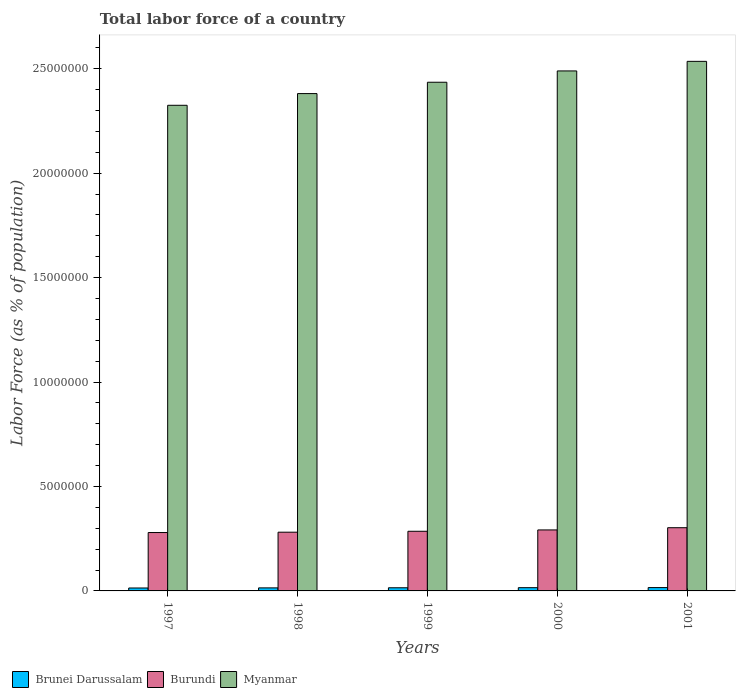How many groups of bars are there?
Your answer should be compact. 5. Are the number of bars per tick equal to the number of legend labels?
Keep it short and to the point. Yes. How many bars are there on the 1st tick from the left?
Your response must be concise. 3. How many bars are there on the 5th tick from the right?
Ensure brevity in your answer.  3. What is the label of the 2nd group of bars from the left?
Offer a very short reply. 1998. What is the percentage of labor force in Brunei Darussalam in 1999?
Offer a very short reply. 1.51e+05. Across all years, what is the maximum percentage of labor force in Burundi?
Your response must be concise. 3.03e+06. Across all years, what is the minimum percentage of labor force in Burundi?
Give a very brief answer. 2.79e+06. What is the total percentage of labor force in Myanmar in the graph?
Ensure brevity in your answer.  1.22e+08. What is the difference between the percentage of labor force in Brunei Darussalam in 1998 and that in 2000?
Provide a short and direct response. -1.00e+04. What is the difference between the percentage of labor force in Myanmar in 2000 and the percentage of labor force in Brunei Darussalam in 2001?
Provide a succinct answer. 2.47e+07. What is the average percentage of labor force in Brunei Darussalam per year?
Give a very brief answer. 1.50e+05. In the year 2000, what is the difference between the percentage of labor force in Burundi and percentage of labor force in Myanmar?
Make the answer very short. -2.20e+07. What is the ratio of the percentage of labor force in Burundi in 1997 to that in 2001?
Provide a succinct answer. 0.92. Is the percentage of labor force in Myanmar in 1999 less than that in 2001?
Provide a succinct answer. Yes. What is the difference between the highest and the second highest percentage of labor force in Myanmar?
Provide a short and direct response. 4.58e+05. What is the difference between the highest and the lowest percentage of labor force in Myanmar?
Ensure brevity in your answer.  2.10e+06. What does the 3rd bar from the left in 2000 represents?
Keep it short and to the point. Myanmar. What does the 3rd bar from the right in 2000 represents?
Provide a short and direct response. Brunei Darussalam. Is it the case that in every year, the sum of the percentage of labor force in Myanmar and percentage of labor force in Brunei Darussalam is greater than the percentage of labor force in Burundi?
Offer a very short reply. Yes. How many bars are there?
Provide a succinct answer. 15. Are all the bars in the graph horizontal?
Your response must be concise. No. How many years are there in the graph?
Your answer should be very brief. 5. What is the difference between two consecutive major ticks on the Y-axis?
Make the answer very short. 5.00e+06. Does the graph contain grids?
Make the answer very short. No. How are the legend labels stacked?
Your answer should be very brief. Horizontal. What is the title of the graph?
Give a very brief answer. Total labor force of a country. Does "High income: OECD" appear as one of the legend labels in the graph?
Offer a very short reply. No. What is the label or title of the Y-axis?
Provide a short and direct response. Labor Force (as % of population). What is the Labor Force (as % of population) in Brunei Darussalam in 1997?
Your response must be concise. 1.41e+05. What is the Labor Force (as % of population) of Burundi in 1997?
Provide a short and direct response. 2.79e+06. What is the Labor Force (as % of population) in Myanmar in 1997?
Your answer should be compact. 2.32e+07. What is the Labor Force (as % of population) in Brunei Darussalam in 1998?
Provide a succinct answer. 1.45e+05. What is the Labor Force (as % of population) in Burundi in 1998?
Ensure brevity in your answer.  2.81e+06. What is the Labor Force (as % of population) of Myanmar in 1998?
Provide a succinct answer. 2.38e+07. What is the Labor Force (as % of population) in Brunei Darussalam in 1999?
Provide a succinct answer. 1.51e+05. What is the Labor Force (as % of population) of Burundi in 1999?
Make the answer very short. 2.86e+06. What is the Labor Force (as % of population) of Myanmar in 1999?
Ensure brevity in your answer.  2.44e+07. What is the Labor Force (as % of population) in Brunei Darussalam in 2000?
Ensure brevity in your answer.  1.55e+05. What is the Labor Force (as % of population) in Burundi in 2000?
Keep it short and to the point. 2.92e+06. What is the Labor Force (as % of population) of Myanmar in 2000?
Offer a terse response. 2.49e+07. What is the Labor Force (as % of population) in Brunei Darussalam in 2001?
Offer a very short reply. 1.60e+05. What is the Labor Force (as % of population) in Burundi in 2001?
Ensure brevity in your answer.  3.03e+06. What is the Labor Force (as % of population) in Myanmar in 2001?
Make the answer very short. 2.54e+07. Across all years, what is the maximum Labor Force (as % of population) in Brunei Darussalam?
Keep it short and to the point. 1.60e+05. Across all years, what is the maximum Labor Force (as % of population) in Burundi?
Offer a very short reply. 3.03e+06. Across all years, what is the maximum Labor Force (as % of population) in Myanmar?
Ensure brevity in your answer.  2.54e+07. Across all years, what is the minimum Labor Force (as % of population) of Brunei Darussalam?
Provide a succinct answer. 1.41e+05. Across all years, what is the minimum Labor Force (as % of population) of Burundi?
Provide a short and direct response. 2.79e+06. Across all years, what is the minimum Labor Force (as % of population) in Myanmar?
Provide a short and direct response. 2.32e+07. What is the total Labor Force (as % of population) of Brunei Darussalam in the graph?
Your response must be concise. 7.52e+05. What is the total Labor Force (as % of population) of Burundi in the graph?
Make the answer very short. 1.44e+07. What is the total Labor Force (as % of population) of Myanmar in the graph?
Offer a terse response. 1.22e+08. What is the difference between the Labor Force (as % of population) of Brunei Darussalam in 1997 and that in 1998?
Your response must be concise. -4952. What is the difference between the Labor Force (as % of population) in Burundi in 1997 and that in 1998?
Offer a terse response. -1.61e+04. What is the difference between the Labor Force (as % of population) of Myanmar in 1997 and that in 1998?
Your response must be concise. -5.60e+05. What is the difference between the Labor Force (as % of population) of Brunei Darussalam in 1997 and that in 1999?
Make the answer very short. -1.00e+04. What is the difference between the Labor Force (as % of population) in Burundi in 1997 and that in 1999?
Your answer should be very brief. -6.08e+04. What is the difference between the Labor Force (as % of population) in Myanmar in 1997 and that in 1999?
Provide a short and direct response. -1.10e+06. What is the difference between the Labor Force (as % of population) of Brunei Darussalam in 1997 and that in 2000?
Provide a short and direct response. -1.50e+04. What is the difference between the Labor Force (as % of population) in Burundi in 1997 and that in 2000?
Your answer should be compact. -1.25e+05. What is the difference between the Labor Force (as % of population) in Myanmar in 1997 and that in 2000?
Your answer should be very brief. -1.64e+06. What is the difference between the Labor Force (as % of population) in Brunei Darussalam in 1997 and that in 2001?
Keep it short and to the point. -1.95e+04. What is the difference between the Labor Force (as % of population) of Burundi in 1997 and that in 2001?
Your response must be concise. -2.31e+05. What is the difference between the Labor Force (as % of population) of Myanmar in 1997 and that in 2001?
Offer a terse response. -2.10e+06. What is the difference between the Labor Force (as % of population) in Brunei Darussalam in 1998 and that in 1999?
Offer a terse response. -5076. What is the difference between the Labor Force (as % of population) of Burundi in 1998 and that in 1999?
Offer a terse response. -4.47e+04. What is the difference between the Labor Force (as % of population) of Myanmar in 1998 and that in 1999?
Your answer should be compact. -5.44e+05. What is the difference between the Labor Force (as % of population) in Brunei Darussalam in 1998 and that in 2000?
Your answer should be compact. -1.00e+04. What is the difference between the Labor Force (as % of population) of Burundi in 1998 and that in 2000?
Provide a short and direct response. -1.09e+05. What is the difference between the Labor Force (as % of population) of Myanmar in 1998 and that in 2000?
Keep it short and to the point. -1.09e+06. What is the difference between the Labor Force (as % of population) of Brunei Darussalam in 1998 and that in 2001?
Your answer should be very brief. -1.46e+04. What is the difference between the Labor Force (as % of population) in Burundi in 1998 and that in 2001?
Make the answer very short. -2.15e+05. What is the difference between the Labor Force (as % of population) of Myanmar in 1998 and that in 2001?
Give a very brief answer. -1.54e+06. What is the difference between the Labor Force (as % of population) of Brunei Darussalam in 1999 and that in 2000?
Your answer should be compact. -4948. What is the difference between the Labor Force (as % of population) in Burundi in 1999 and that in 2000?
Your response must be concise. -6.41e+04. What is the difference between the Labor Force (as % of population) in Myanmar in 1999 and that in 2000?
Offer a terse response. -5.42e+05. What is the difference between the Labor Force (as % of population) in Brunei Darussalam in 1999 and that in 2001?
Offer a terse response. -9478. What is the difference between the Labor Force (as % of population) of Burundi in 1999 and that in 2001?
Make the answer very short. -1.70e+05. What is the difference between the Labor Force (as % of population) in Myanmar in 1999 and that in 2001?
Offer a terse response. -1.00e+06. What is the difference between the Labor Force (as % of population) in Brunei Darussalam in 2000 and that in 2001?
Your answer should be compact. -4530. What is the difference between the Labor Force (as % of population) of Burundi in 2000 and that in 2001?
Make the answer very short. -1.06e+05. What is the difference between the Labor Force (as % of population) in Myanmar in 2000 and that in 2001?
Give a very brief answer. -4.58e+05. What is the difference between the Labor Force (as % of population) in Brunei Darussalam in 1997 and the Labor Force (as % of population) in Burundi in 1998?
Keep it short and to the point. -2.67e+06. What is the difference between the Labor Force (as % of population) in Brunei Darussalam in 1997 and the Labor Force (as % of population) in Myanmar in 1998?
Offer a very short reply. -2.37e+07. What is the difference between the Labor Force (as % of population) in Burundi in 1997 and the Labor Force (as % of population) in Myanmar in 1998?
Offer a terse response. -2.10e+07. What is the difference between the Labor Force (as % of population) in Brunei Darussalam in 1997 and the Labor Force (as % of population) in Burundi in 1999?
Give a very brief answer. -2.72e+06. What is the difference between the Labor Force (as % of population) of Brunei Darussalam in 1997 and the Labor Force (as % of population) of Myanmar in 1999?
Your answer should be very brief. -2.42e+07. What is the difference between the Labor Force (as % of population) in Burundi in 1997 and the Labor Force (as % of population) in Myanmar in 1999?
Keep it short and to the point. -2.16e+07. What is the difference between the Labor Force (as % of population) in Brunei Darussalam in 1997 and the Labor Force (as % of population) in Burundi in 2000?
Your response must be concise. -2.78e+06. What is the difference between the Labor Force (as % of population) of Brunei Darussalam in 1997 and the Labor Force (as % of population) of Myanmar in 2000?
Your response must be concise. -2.48e+07. What is the difference between the Labor Force (as % of population) in Burundi in 1997 and the Labor Force (as % of population) in Myanmar in 2000?
Your response must be concise. -2.21e+07. What is the difference between the Labor Force (as % of population) in Brunei Darussalam in 1997 and the Labor Force (as % of population) in Burundi in 2001?
Ensure brevity in your answer.  -2.89e+06. What is the difference between the Labor Force (as % of population) in Brunei Darussalam in 1997 and the Labor Force (as % of population) in Myanmar in 2001?
Your answer should be compact. -2.52e+07. What is the difference between the Labor Force (as % of population) of Burundi in 1997 and the Labor Force (as % of population) of Myanmar in 2001?
Your response must be concise. -2.26e+07. What is the difference between the Labor Force (as % of population) in Brunei Darussalam in 1998 and the Labor Force (as % of population) in Burundi in 1999?
Make the answer very short. -2.71e+06. What is the difference between the Labor Force (as % of population) in Brunei Darussalam in 1998 and the Labor Force (as % of population) in Myanmar in 1999?
Offer a very short reply. -2.42e+07. What is the difference between the Labor Force (as % of population) of Burundi in 1998 and the Labor Force (as % of population) of Myanmar in 1999?
Ensure brevity in your answer.  -2.15e+07. What is the difference between the Labor Force (as % of population) in Brunei Darussalam in 1998 and the Labor Force (as % of population) in Burundi in 2000?
Keep it short and to the point. -2.77e+06. What is the difference between the Labor Force (as % of population) of Brunei Darussalam in 1998 and the Labor Force (as % of population) of Myanmar in 2000?
Your response must be concise. -2.47e+07. What is the difference between the Labor Force (as % of population) in Burundi in 1998 and the Labor Force (as % of population) in Myanmar in 2000?
Your response must be concise. -2.21e+07. What is the difference between the Labor Force (as % of population) in Brunei Darussalam in 1998 and the Labor Force (as % of population) in Burundi in 2001?
Offer a terse response. -2.88e+06. What is the difference between the Labor Force (as % of population) of Brunei Darussalam in 1998 and the Labor Force (as % of population) of Myanmar in 2001?
Your answer should be very brief. -2.52e+07. What is the difference between the Labor Force (as % of population) of Burundi in 1998 and the Labor Force (as % of population) of Myanmar in 2001?
Your answer should be very brief. -2.25e+07. What is the difference between the Labor Force (as % of population) of Brunei Darussalam in 1999 and the Labor Force (as % of population) of Burundi in 2000?
Offer a terse response. -2.77e+06. What is the difference between the Labor Force (as % of population) of Brunei Darussalam in 1999 and the Labor Force (as % of population) of Myanmar in 2000?
Provide a short and direct response. -2.47e+07. What is the difference between the Labor Force (as % of population) of Burundi in 1999 and the Labor Force (as % of population) of Myanmar in 2000?
Keep it short and to the point. -2.20e+07. What is the difference between the Labor Force (as % of population) of Brunei Darussalam in 1999 and the Labor Force (as % of population) of Burundi in 2001?
Offer a terse response. -2.88e+06. What is the difference between the Labor Force (as % of population) in Brunei Darussalam in 1999 and the Labor Force (as % of population) in Myanmar in 2001?
Your response must be concise. -2.52e+07. What is the difference between the Labor Force (as % of population) of Burundi in 1999 and the Labor Force (as % of population) of Myanmar in 2001?
Make the answer very short. -2.25e+07. What is the difference between the Labor Force (as % of population) in Brunei Darussalam in 2000 and the Labor Force (as % of population) in Burundi in 2001?
Provide a succinct answer. -2.87e+06. What is the difference between the Labor Force (as % of population) in Brunei Darussalam in 2000 and the Labor Force (as % of population) in Myanmar in 2001?
Make the answer very short. -2.52e+07. What is the difference between the Labor Force (as % of population) of Burundi in 2000 and the Labor Force (as % of population) of Myanmar in 2001?
Give a very brief answer. -2.24e+07. What is the average Labor Force (as % of population) of Brunei Darussalam per year?
Provide a succinct answer. 1.50e+05. What is the average Labor Force (as % of population) in Burundi per year?
Provide a short and direct response. 2.88e+06. What is the average Labor Force (as % of population) of Myanmar per year?
Provide a succinct answer. 2.43e+07. In the year 1997, what is the difference between the Labor Force (as % of population) in Brunei Darussalam and Labor Force (as % of population) in Burundi?
Make the answer very short. -2.65e+06. In the year 1997, what is the difference between the Labor Force (as % of population) of Brunei Darussalam and Labor Force (as % of population) of Myanmar?
Keep it short and to the point. -2.31e+07. In the year 1997, what is the difference between the Labor Force (as % of population) of Burundi and Labor Force (as % of population) of Myanmar?
Provide a succinct answer. -2.05e+07. In the year 1998, what is the difference between the Labor Force (as % of population) in Brunei Darussalam and Labor Force (as % of population) in Burundi?
Your answer should be very brief. -2.67e+06. In the year 1998, what is the difference between the Labor Force (as % of population) in Brunei Darussalam and Labor Force (as % of population) in Myanmar?
Give a very brief answer. -2.37e+07. In the year 1998, what is the difference between the Labor Force (as % of population) in Burundi and Labor Force (as % of population) in Myanmar?
Your answer should be very brief. -2.10e+07. In the year 1999, what is the difference between the Labor Force (as % of population) of Brunei Darussalam and Labor Force (as % of population) of Burundi?
Your answer should be compact. -2.71e+06. In the year 1999, what is the difference between the Labor Force (as % of population) of Brunei Darussalam and Labor Force (as % of population) of Myanmar?
Provide a short and direct response. -2.42e+07. In the year 1999, what is the difference between the Labor Force (as % of population) of Burundi and Labor Force (as % of population) of Myanmar?
Ensure brevity in your answer.  -2.15e+07. In the year 2000, what is the difference between the Labor Force (as % of population) of Brunei Darussalam and Labor Force (as % of population) of Burundi?
Give a very brief answer. -2.76e+06. In the year 2000, what is the difference between the Labor Force (as % of population) of Brunei Darussalam and Labor Force (as % of population) of Myanmar?
Ensure brevity in your answer.  -2.47e+07. In the year 2000, what is the difference between the Labor Force (as % of population) in Burundi and Labor Force (as % of population) in Myanmar?
Keep it short and to the point. -2.20e+07. In the year 2001, what is the difference between the Labor Force (as % of population) of Brunei Darussalam and Labor Force (as % of population) of Burundi?
Give a very brief answer. -2.87e+06. In the year 2001, what is the difference between the Labor Force (as % of population) of Brunei Darussalam and Labor Force (as % of population) of Myanmar?
Provide a short and direct response. -2.52e+07. In the year 2001, what is the difference between the Labor Force (as % of population) of Burundi and Labor Force (as % of population) of Myanmar?
Provide a short and direct response. -2.23e+07. What is the ratio of the Labor Force (as % of population) of Brunei Darussalam in 1997 to that in 1998?
Give a very brief answer. 0.97. What is the ratio of the Labor Force (as % of population) of Burundi in 1997 to that in 1998?
Your answer should be very brief. 0.99. What is the ratio of the Labor Force (as % of population) in Myanmar in 1997 to that in 1998?
Your answer should be very brief. 0.98. What is the ratio of the Labor Force (as % of population) of Brunei Darussalam in 1997 to that in 1999?
Your answer should be very brief. 0.93. What is the ratio of the Labor Force (as % of population) of Burundi in 1997 to that in 1999?
Keep it short and to the point. 0.98. What is the ratio of the Labor Force (as % of population) of Myanmar in 1997 to that in 1999?
Offer a very short reply. 0.95. What is the ratio of the Labor Force (as % of population) of Brunei Darussalam in 1997 to that in 2000?
Ensure brevity in your answer.  0.9. What is the ratio of the Labor Force (as % of population) of Burundi in 1997 to that in 2000?
Offer a terse response. 0.96. What is the ratio of the Labor Force (as % of population) in Myanmar in 1997 to that in 2000?
Your answer should be compact. 0.93. What is the ratio of the Labor Force (as % of population) in Brunei Darussalam in 1997 to that in 2001?
Provide a succinct answer. 0.88. What is the ratio of the Labor Force (as % of population) of Burundi in 1997 to that in 2001?
Give a very brief answer. 0.92. What is the ratio of the Labor Force (as % of population) in Myanmar in 1997 to that in 2001?
Your response must be concise. 0.92. What is the ratio of the Labor Force (as % of population) of Brunei Darussalam in 1998 to that in 1999?
Provide a short and direct response. 0.97. What is the ratio of the Labor Force (as % of population) in Burundi in 1998 to that in 1999?
Provide a short and direct response. 0.98. What is the ratio of the Labor Force (as % of population) in Myanmar in 1998 to that in 1999?
Your answer should be compact. 0.98. What is the ratio of the Labor Force (as % of population) in Brunei Darussalam in 1998 to that in 2000?
Offer a very short reply. 0.94. What is the ratio of the Labor Force (as % of population) in Burundi in 1998 to that in 2000?
Keep it short and to the point. 0.96. What is the ratio of the Labor Force (as % of population) of Myanmar in 1998 to that in 2000?
Give a very brief answer. 0.96. What is the ratio of the Labor Force (as % of population) of Brunei Darussalam in 1998 to that in 2001?
Ensure brevity in your answer.  0.91. What is the ratio of the Labor Force (as % of population) in Burundi in 1998 to that in 2001?
Offer a very short reply. 0.93. What is the ratio of the Labor Force (as % of population) in Myanmar in 1998 to that in 2001?
Provide a succinct answer. 0.94. What is the ratio of the Labor Force (as % of population) of Brunei Darussalam in 1999 to that in 2000?
Make the answer very short. 0.97. What is the ratio of the Labor Force (as % of population) of Burundi in 1999 to that in 2000?
Your answer should be very brief. 0.98. What is the ratio of the Labor Force (as % of population) in Myanmar in 1999 to that in 2000?
Offer a very short reply. 0.98. What is the ratio of the Labor Force (as % of population) in Brunei Darussalam in 1999 to that in 2001?
Ensure brevity in your answer.  0.94. What is the ratio of the Labor Force (as % of population) in Burundi in 1999 to that in 2001?
Your answer should be compact. 0.94. What is the ratio of the Labor Force (as % of population) of Myanmar in 1999 to that in 2001?
Ensure brevity in your answer.  0.96. What is the ratio of the Labor Force (as % of population) in Brunei Darussalam in 2000 to that in 2001?
Offer a very short reply. 0.97. What is the ratio of the Labor Force (as % of population) in Burundi in 2000 to that in 2001?
Offer a terse response. 0.96. What is the ratio of the Labor Force (as % of population) of Myanmar in 2000 to that in 2001?
Your answer should be compact. 0.98. What is the difference between the highest and the second highest Labor Force (as % of population) in Brunei Darussalam?
Your answer should be compact. 4530. What is the difference between the highest and the second highest Labor Force (as % of population) of Burundi?
Offer a very short reply. 1.06e+05. What is the difference between the highest and the second highest Labor Force (as % of population) of Myanmar?
Keep it short and to the point. 4.58e+05. What is the difference between the highest and the lowest Labor Force (as % of population) of Brunei Darussalam?
Provide a short and direct response. 1.95e+04. What is the difference between the highest and the lowest Labor Force (as % of population) of Burundi?
Your response must be concise. 2.31e+05. What is the difference between the highest and the lowest Labor Force (as % of population) of Myanmar?
Your response must be concise. 2.10e+06. 